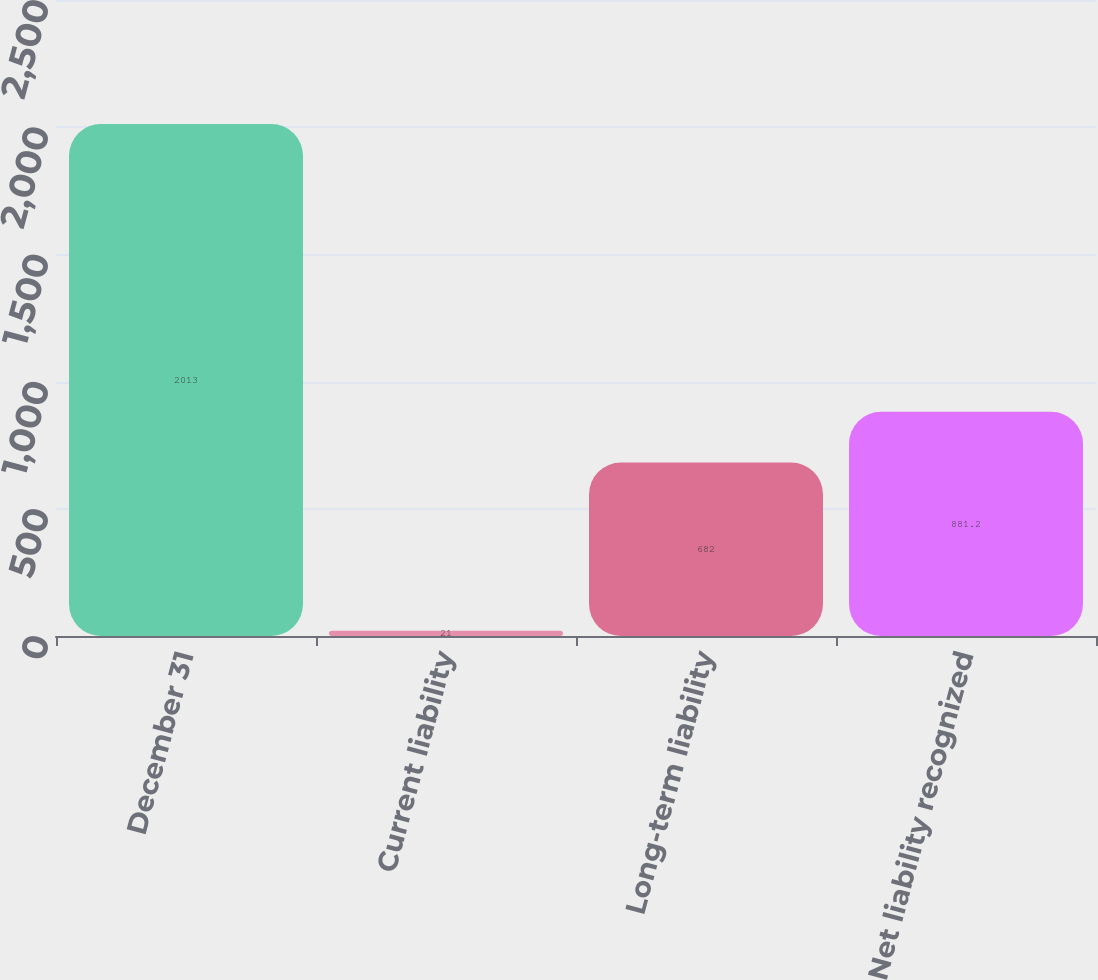<chart> <loc_0><loc_0><loc_500><loc_500><bar_chart><fcel>December 31<fcel>Current liability<fcel>Long-term liability<fcel>Net liability recognized<nl><fcel>2013<fcel>21<fcel>682<fcel>881.2<nl></chart> 